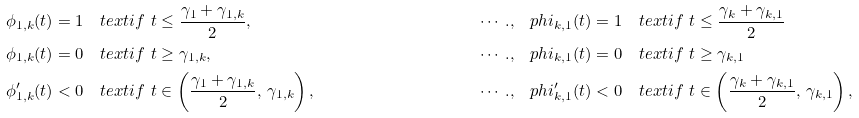Convert formula to latex. <formula><loc_0><loc_0><loc_500><loc_500>\phi _ { 1 , k } ( t ) & = 1 \quad t e x t { i f } \ t \leq \frac { \gamma _ { 1 } + \gamma _ { 1 , k } } { 2 } , & \cdots . , & \quad p h i _ { k , 1 } ( t ) = 1 \quad t e x t { i f } \ t \leq { \frac { \gamma _ { k } + \gamma _ { k , 1 } } { 2 } } \\ \phi _ { 1 , k } ( t ) & = 0 \quad t e x t { i f } \ t \geq \gamma _ { 1 , k } , & \cdots . , & \quad p h i _ { k , 1 } ( t ) = 0 \quad t e x t { i f } \ t \geq \gamma _ { k , 1 } \\ \phi _ { 1 , k } ^ { \prime } ( t ) & < 0 \quad t e x t { i f } \ t \in \left ( \frac { \gamma _ { 1 } + \gamma _ { 1 , k } } { 2 } , \, \gamma _ { 1 , k } \right ) , & \cdots . , & \ \ \ p h i _ { k , 1 } ^ { \prime } ( t ) < 0 \quad t e x t { i f } \ t \in \left ( \frac { \gamma _ { k } + \gamma _ { k , 1 } } { 2 } , \, \gamma _ { k , 1 } \right ) ,</formula> 